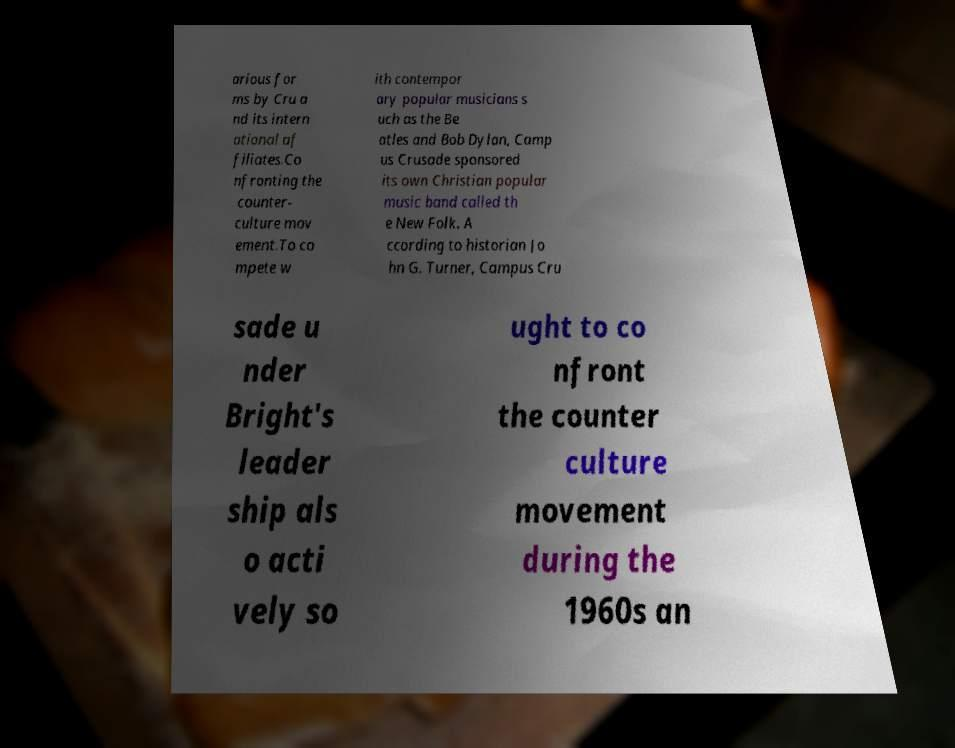Please read and relay the text visible in this image. What does it say? arious for ms by Cru a nd its intern ational af filiates.Co nfronting the counter- culture mov ement.To co mpete w ith contempor ary popular musicians s uch as the Be atles and Bob Dylan, Camp us Crusade sponsored its own Christian popular music band called th e New Folk. A ccording to historian Jo hn G. Turner, Campus Cru sade u nder Bright's leader ship als o acti vely so ught to co nfront the counter culture movement during the 1960s an 